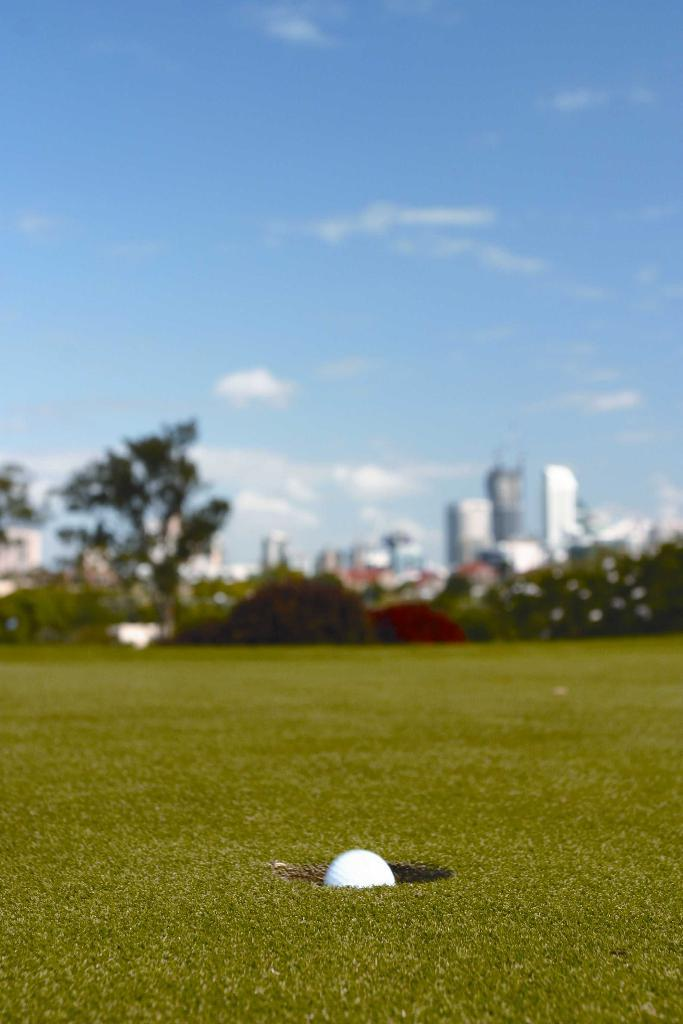What type of vegetation is in the foreground of the image? There is grass in the foreground of the image. What object is placed in the grass? There is a white ball in a hole in the grass. What can be seen in the background of the image? Trees, plants, buildings, and the sky are visible in the background of the image. Can you describe the sky in the image? The sky is visible in the background of the image, and there is a cloud present. What type of juice is being served from the hydrant in the image? There is no hydrant or juice present in the image. What type of blade is being used to cut the grass in the image? There is no blade visible in the image; the grass appears to be natural and not cut. 